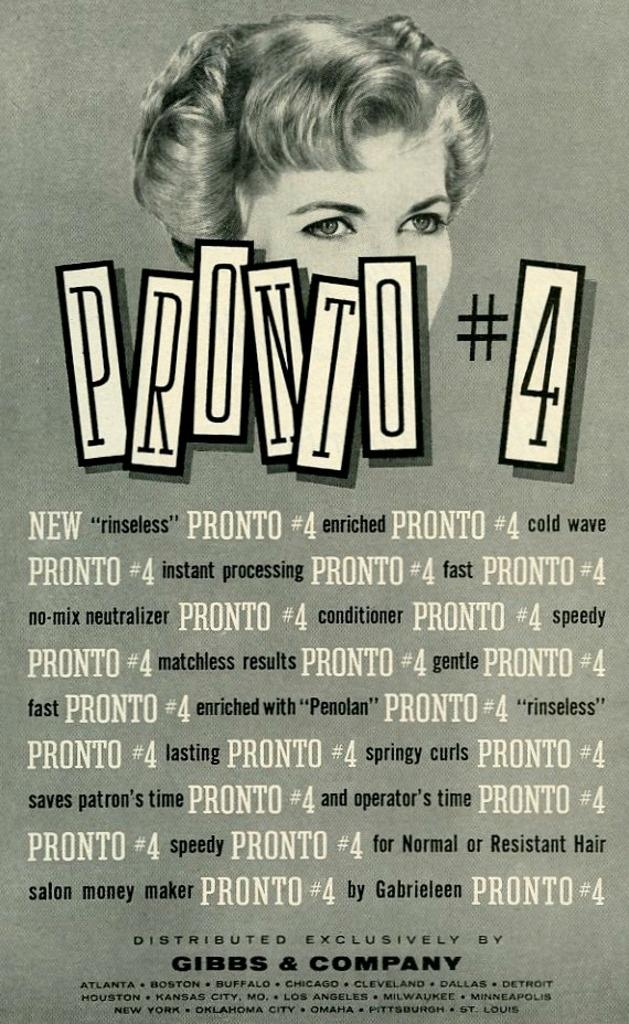<image>
Relay a brief, clear account of the picture shown. The product Pronto #4 is made by Gibbs and Company. 